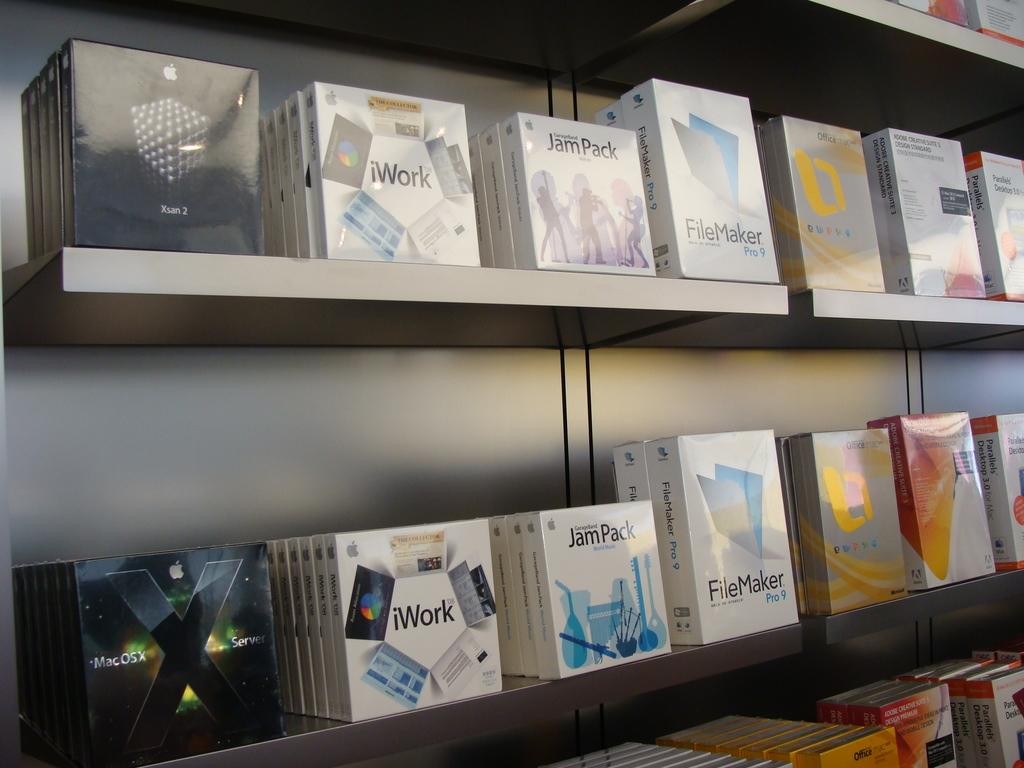Provide a one-sentence caption for the provided image. three shelves with lots of iwork csd on the shelf. 